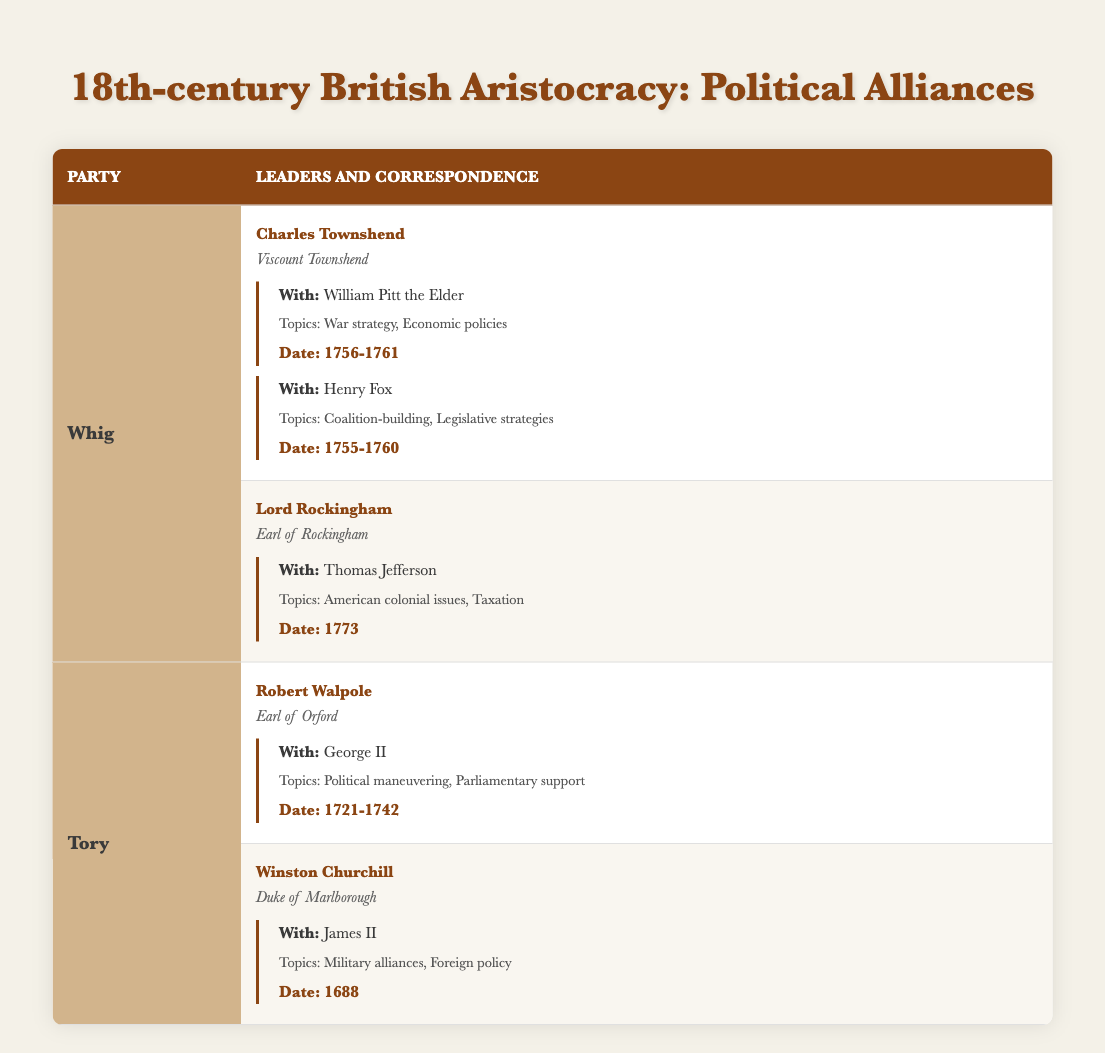What political party did Charles Townshend belong to? From the table, Charles Townshend is listed under the "Whig" party.
Answer: Whig How many leaders are mentioned under the Tory party? The table lists two leaders under the Tory party: Robert Walpole and Winston Churchill.
Answer: 2 What was the primary topic of correspondence between Lord Rockingham and Thomas Jefferson? The primary topics of correspondence listed are "American colonial issues" and "Taxation."
Answer: American colonial issues, Taxation Did Charles Townshend correspond with George II? Referring to the table, Charles Townshend did not correspond with George II; that correspondence belongs to Robert Walpole.
Answer: No Which leader had correspondence about military alliances? Winston Churchill is noted for having correspondence regarding "Military alliances," specifically with James II.
Answer: Winston Churchill How many topics were discussed in the correspondence between Charles Townshend and William Pitt the Elder? The correspondence includes "War strategy" and "Economic policies," totaling two topics.
Answer: 2 Which correspondence was dated the earliest in the table? The correspondence with James II by Winston Churchill is dated 1688, which is the earliest recorded date in the table.
Answer: 1688 Did any correspondence related to taxation occur after the year 1770? According to the table, Lord Rockingham's correspondence with Thomas Jefferson occurred in 1773, which is after 1770.
Answer: Yes What is the total number of distinct correspondences listed in the table? Adding the correspondences: Charles Townshend has 2, Lord Rockingham has 1, Robert Walpole has 1, and Winston Churchill has 1, totaling 5 distinct correspondences.
Answer: 5 